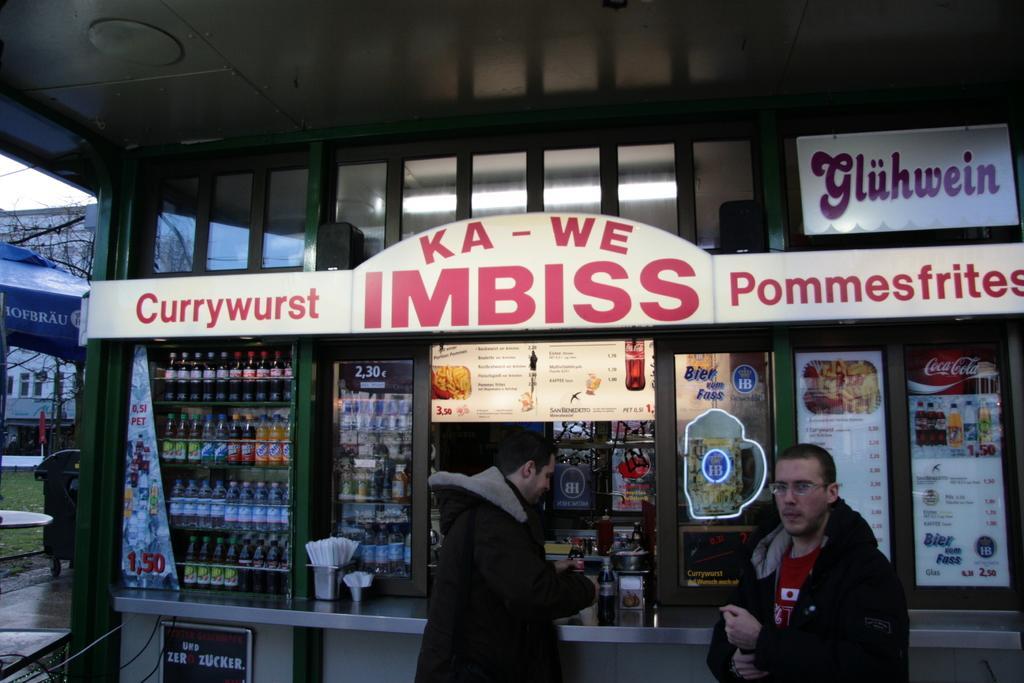Please provide a concise description of this image. In this image I can see two people are standing. Background I can see a stall and I can also see few bottles and few objects on the table. Back I can see a building, windows, blue tent, dustbin and dry tree. 